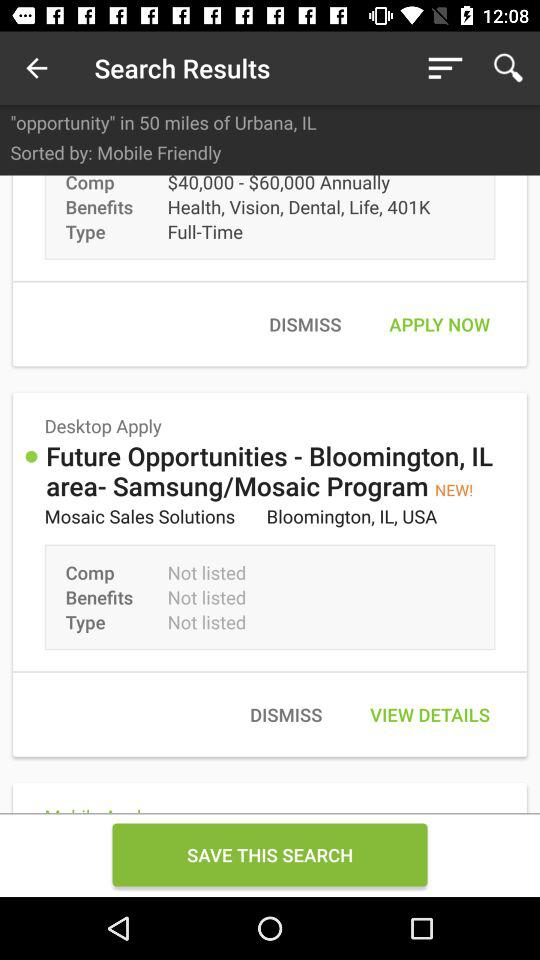What is the type? The types are "Full-Time" and "Not listed". 